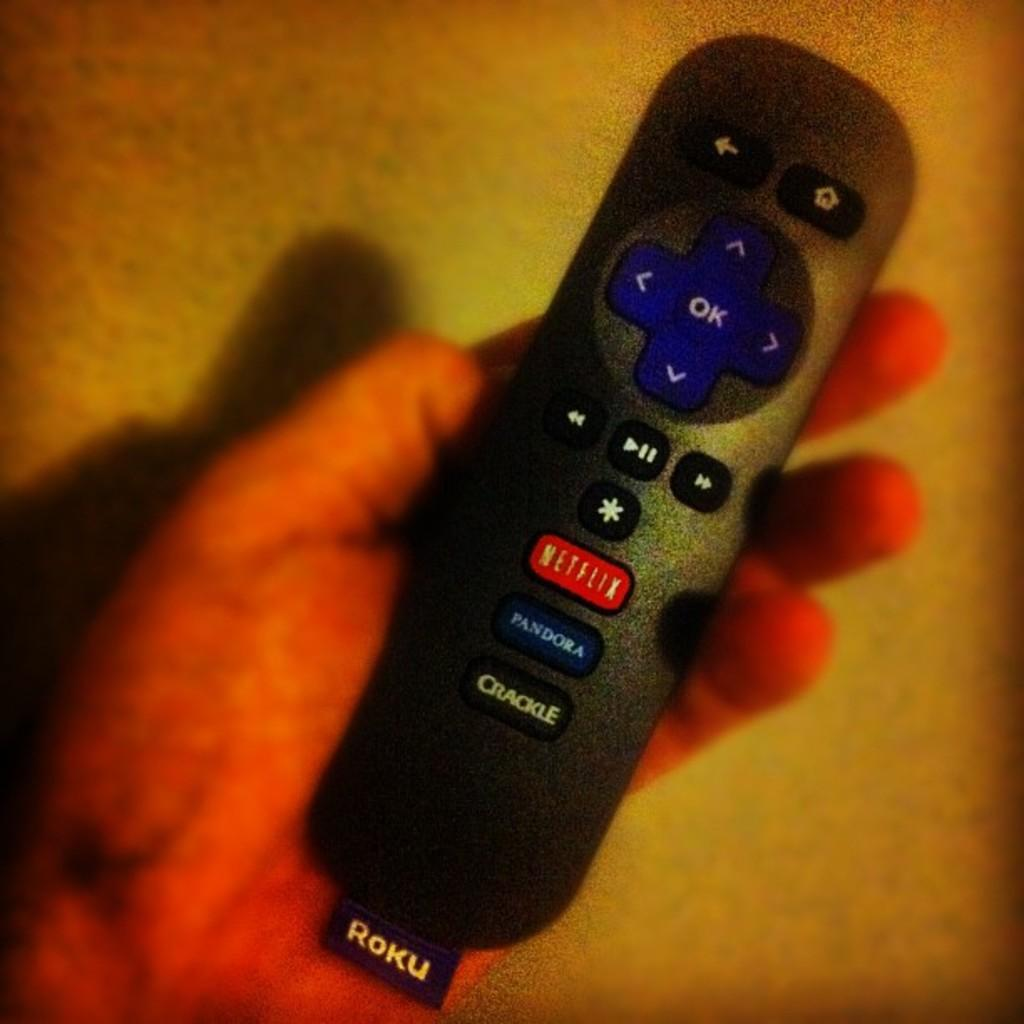Provide a one-sentence caption for the provided image. A Roku TV remote control with buttons for Netflix, Pandora and Crackle. 